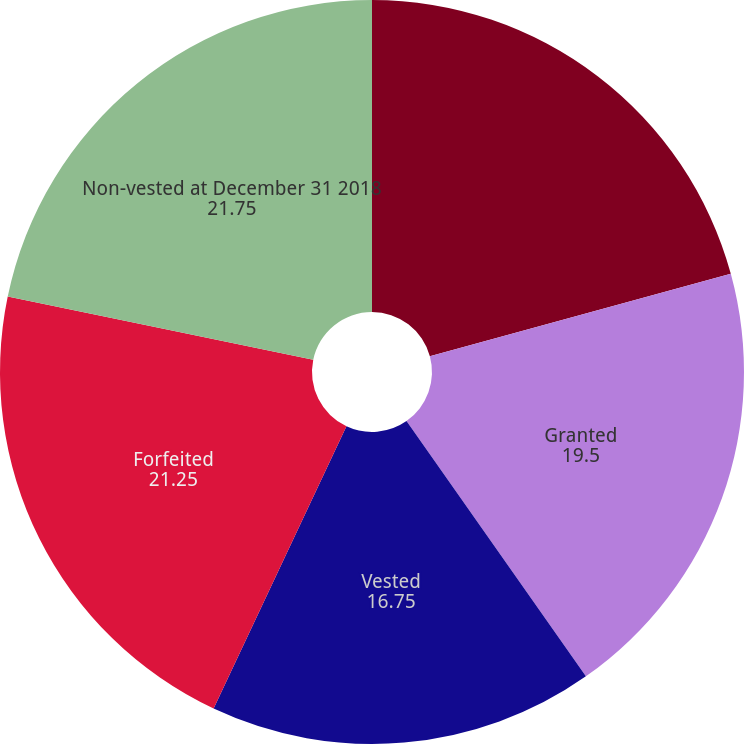<chart> <loc_0><loc_0><loc_500><loc_500><pie_chart><fcel>Non-vested at December 31 2017<fcel>Granted<fcel>Vested<fcel>Forfeited<fcel>Non-vested at December 31 2018<nl><fcel>20.75%<fcel>19.5%<fcel>16.75%<fcel>21.25%<fcel>21.75%<nl></chart> 